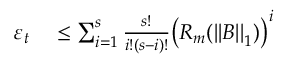<formula> <loc_0><loc_0><loc_500><loc_500>\begin{array} { r l } { \varepsilon _ { t } } & \leq \sum _ { i = 1 } ^ { s } \frac { s ! } { i ! ( s - i ) ! } \left ( R _ { m } ( \left | \left | B \right | \right | _ { 1 } ) \right ) ^ { i } } \end{array}</formula> 